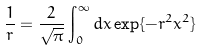<formula> <loc_0><loc_0><loc_500><loc_500>\frac { 1 } { r } = \frac { 2 } { \sqrt { \pi } } \int _ { 0 } ^ { \infty } d x \exp \{ - r ^ { 2 } x ^ { 2 } \}</formula> 